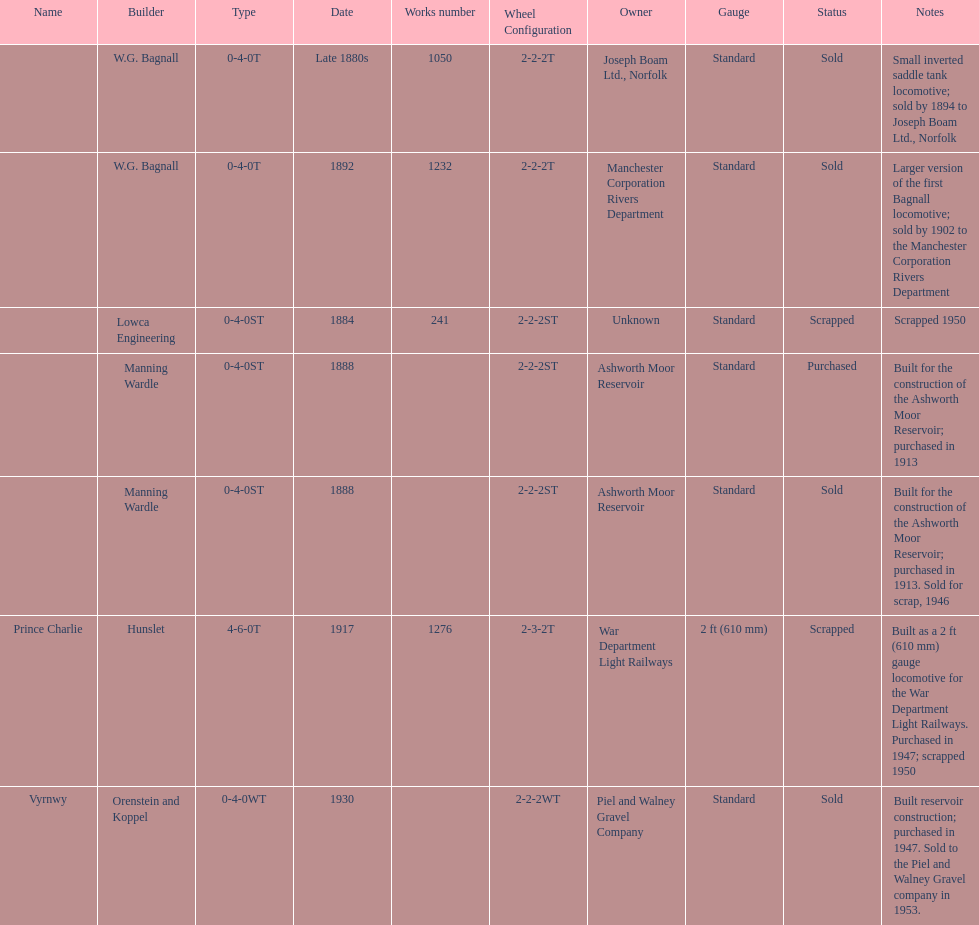What was the last locomotive? Vyrnwy. 